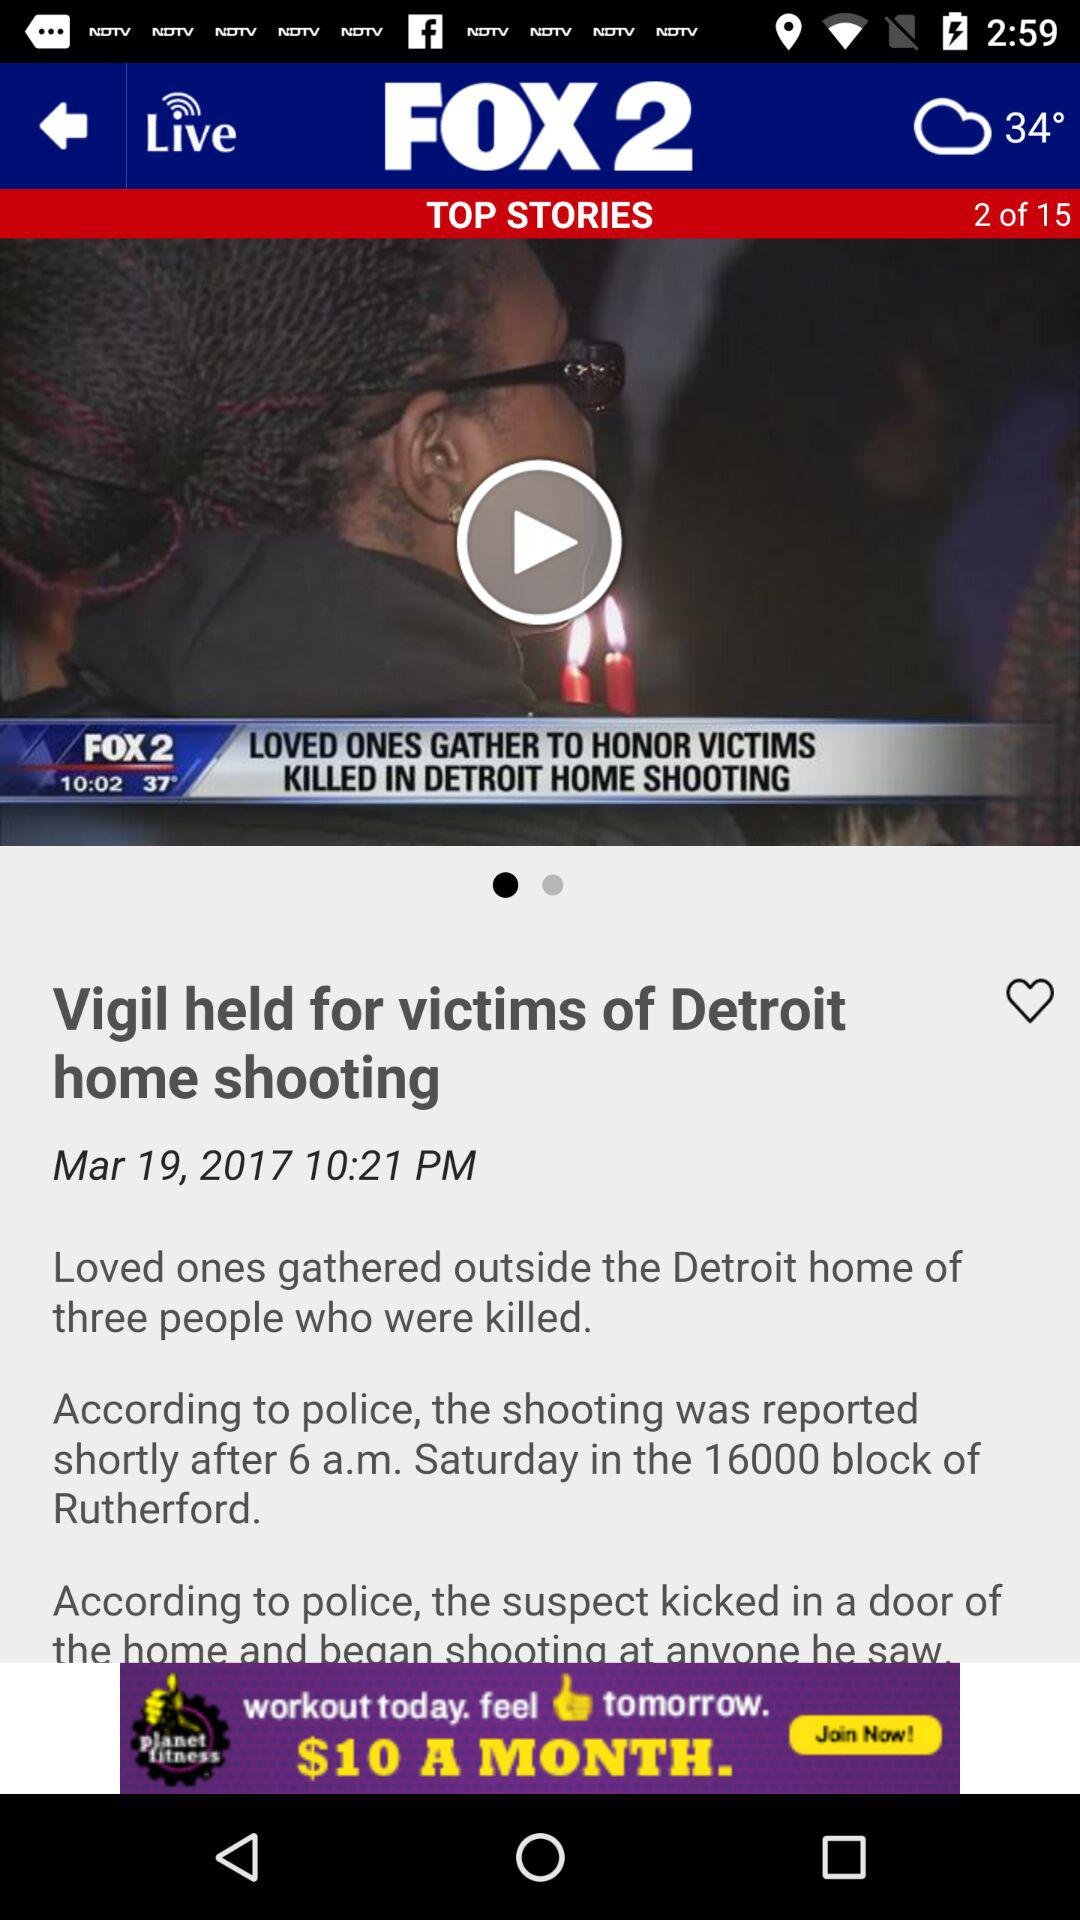At what time was the news updated? The news was updated at 10:21 p.m. 